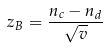<formula> <loc_0><loc_0><loc_500><loc_500>z _ { B } = \frac { n _ { c } - n _ { d } } { \sqrt { v } }</formula> 